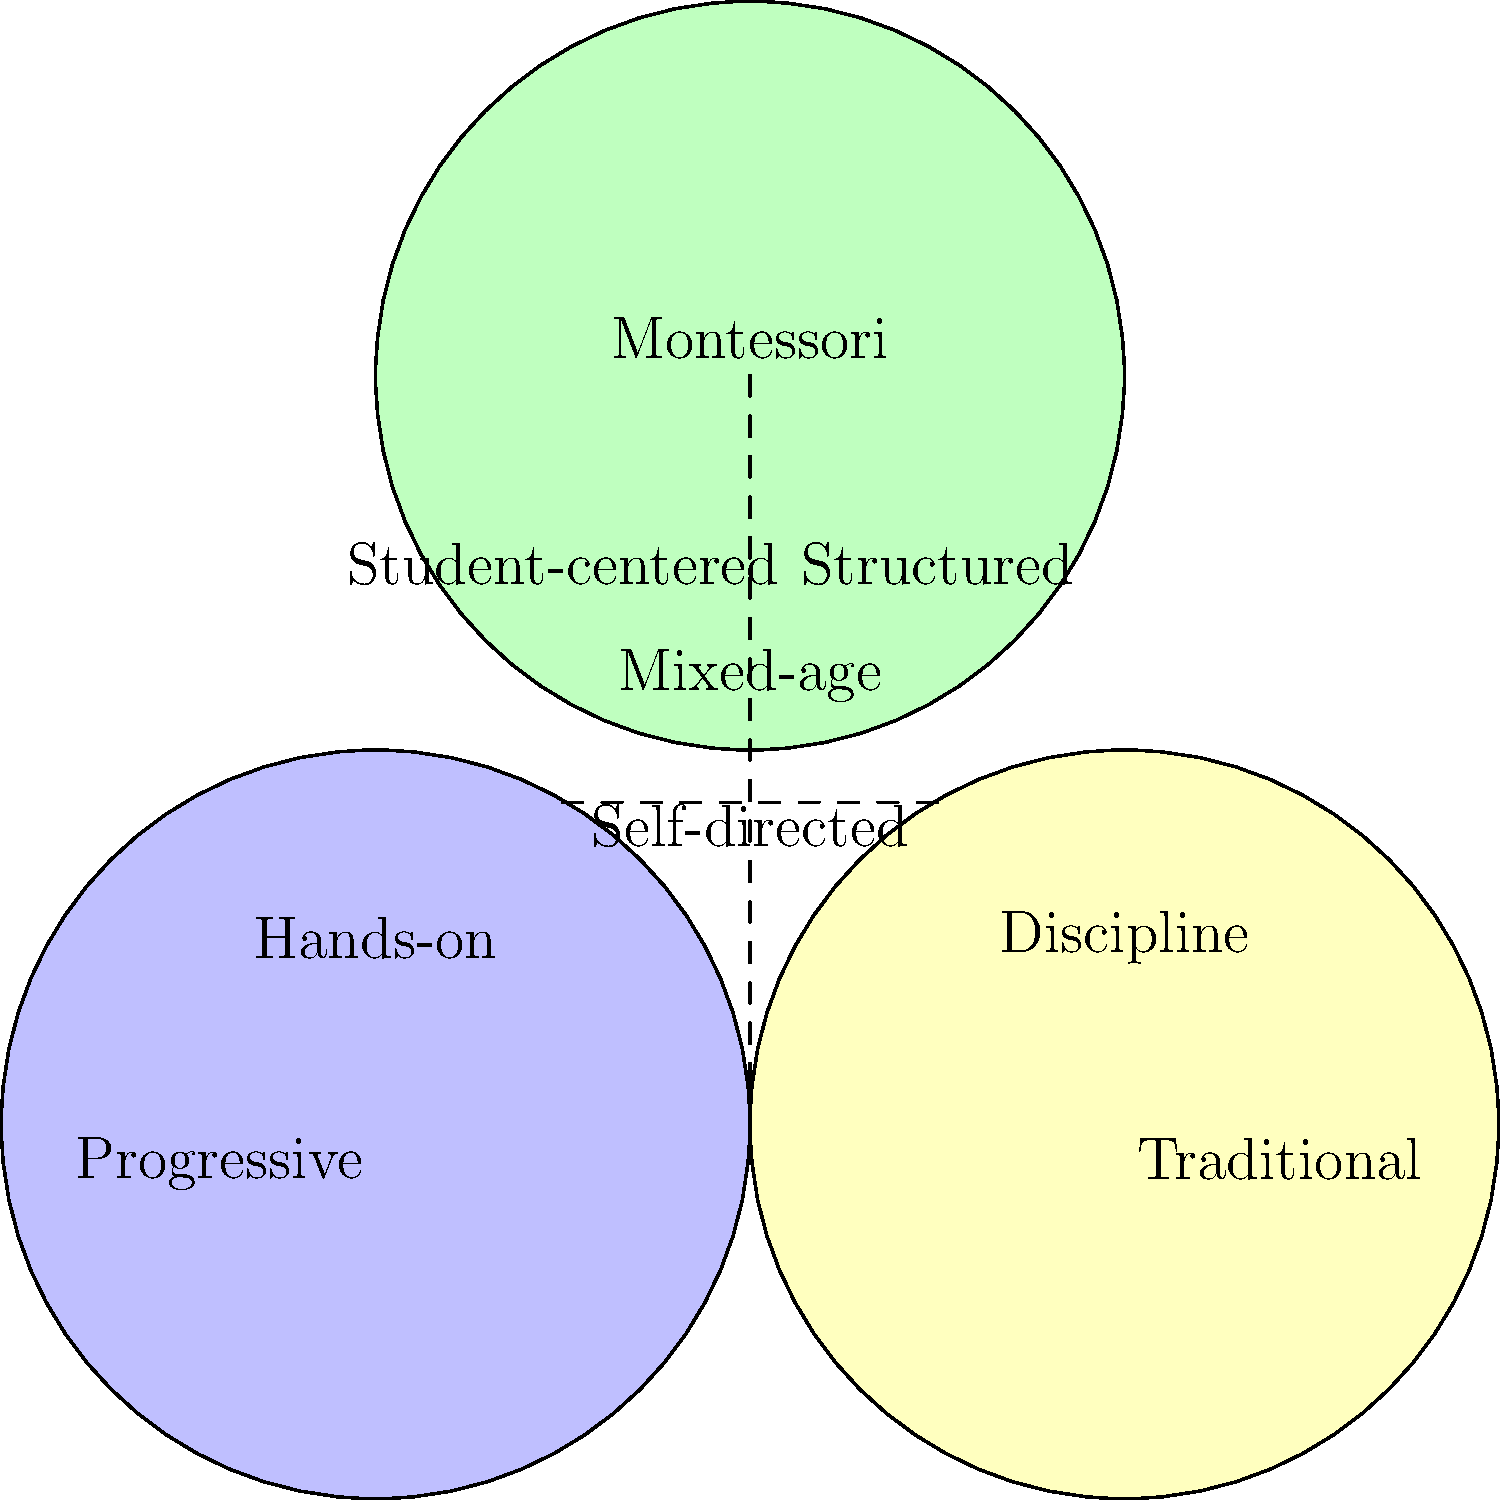Based on the Venn diagram comparing different educational philosophies, which two philosophies share the characteristic of being "Self-directed"? To answer this question, we need to analyze the Venn diagram carefully:

1. The diagram shows three educational philosophies: Progressive, Traditional, and Montessori.

2. Each circle represents one philosophy, and the overlapping areas indicate shared characteristics.

3. We need to locate the term "Self-directed" in the diagram.

4. "Self-directed" is placed in the overlapping area between the Progressive and Montessori circles.

5. This means that both Progressive and Montessori educational philosophies share the characteristic of being "Self-directed".

6. The Traditional philosophy circle does not overlap with this area, indicating it does not share this characteristic.

Therefore, the two philosophies that share the characteristic of being "Self-directed" are Progressive and Montessori.
Answer: Progressive and Montessori 